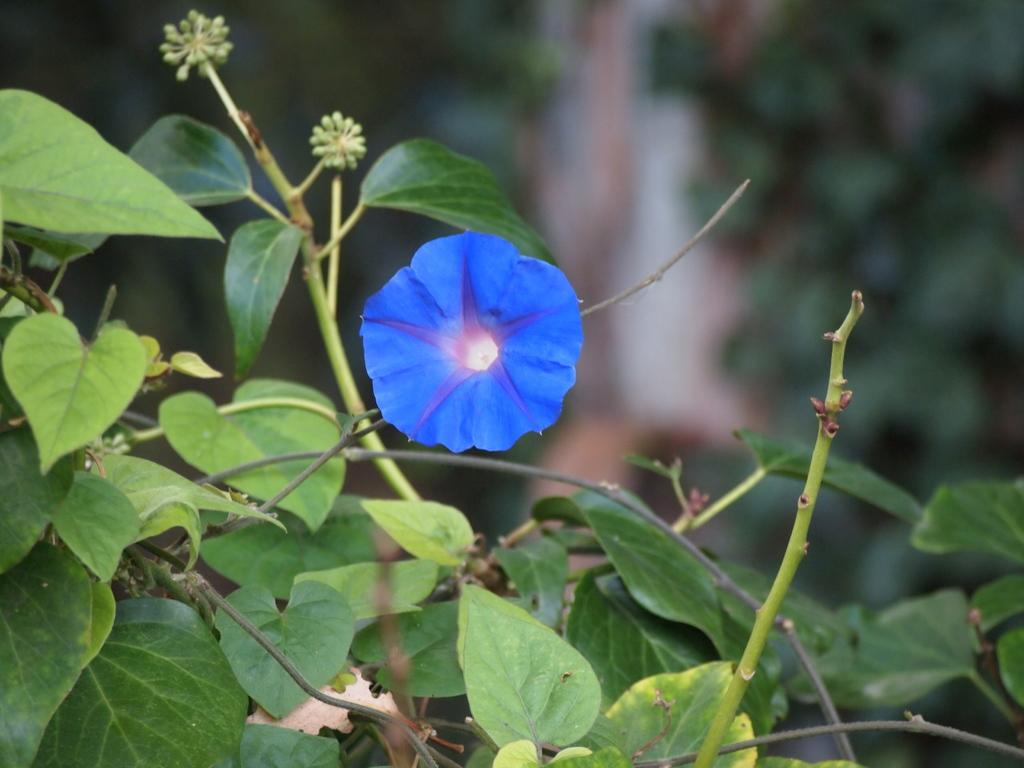What color is the flower in the image? The flower in the image is blue. Where is the flower located? The flower is on a plant. Can you describe the background of the image? The background of the image is blurred. What type of peace symbol can be seen in the image? There is no peace symbol present in the image; it features a blue color flower on a plant with a blurred background. 